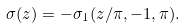Convert formula to latex. <formula><loc_0><loc_0><loc_500><loc_500>\sigma ( z ) = - \sigma _ { 1 } ( z / \pi , - 1 , \pi ) .</formula> 